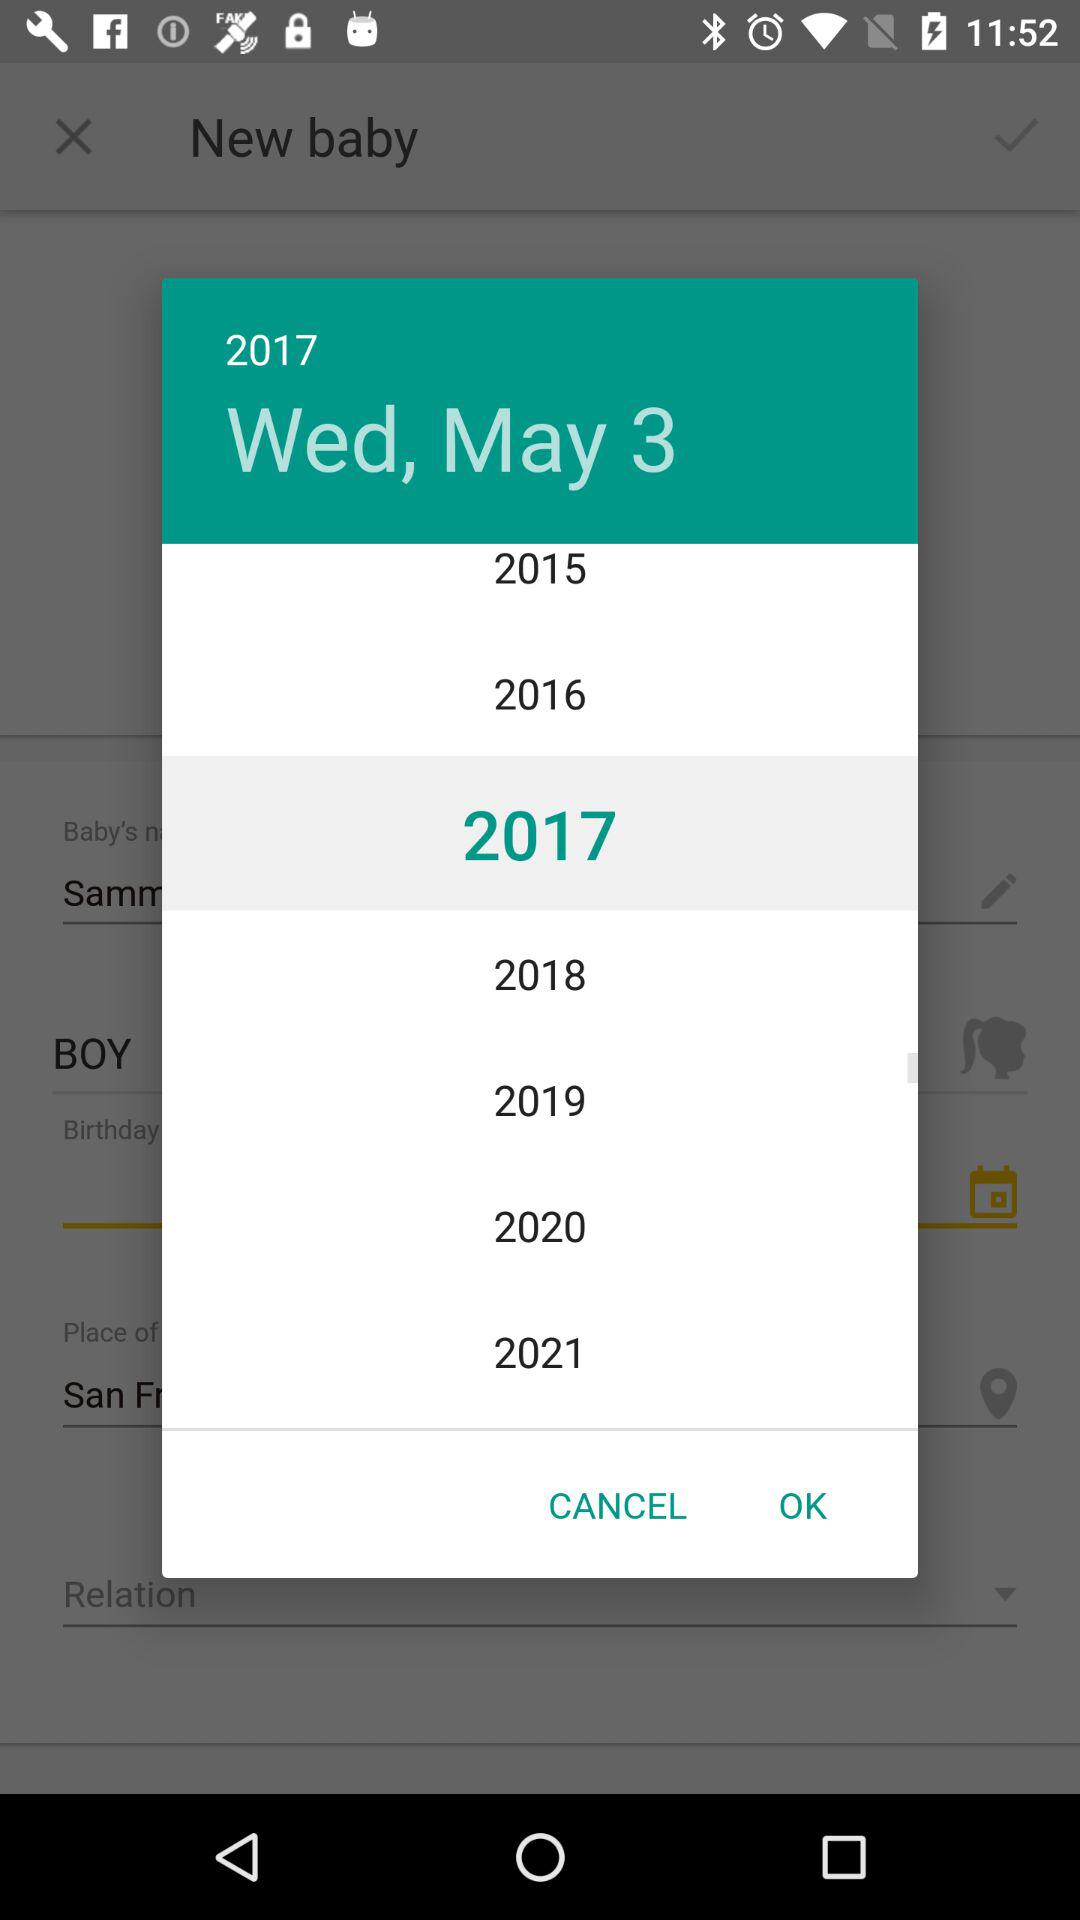Which date is selected? The selected date is Wednesday, May 3, 2017. 